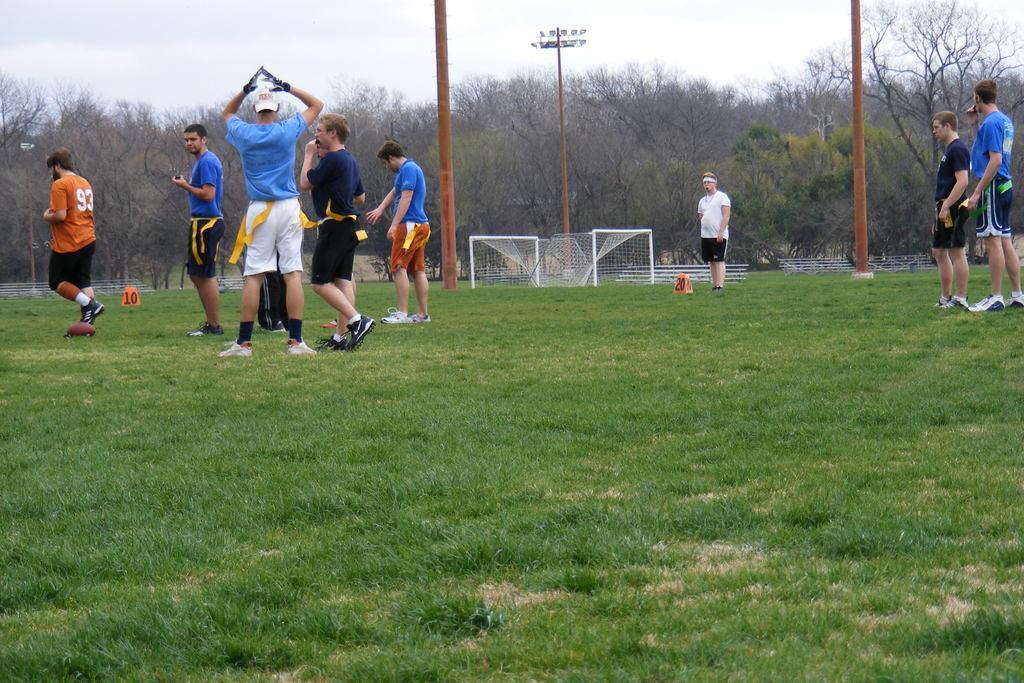In one or two sentences, can you explain what this image depicts? In this image there are group of people standing, and some of them are walking. In the background there are some trees, poles, net and some other objects. At the bottom there is grass, and at the top of the image there is sky. 